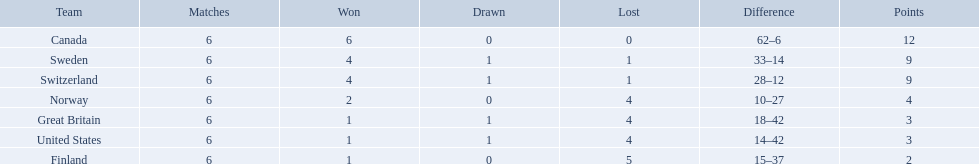Which are the two countries? Switzerland, Great Britain. What were the point totals for each of these countries? 9, 3. Of these point totals, which is better? 9. Which country earned this point total? Switzerland. What are the names of the countries? Canada, Sweden, Switzerland, Norway, Great Britain, United States, Finland. How many wins did switzerland have? 4. How many wins did great britain have? 1. Which country had more wins, great britain or switzerland? Switzerland. 